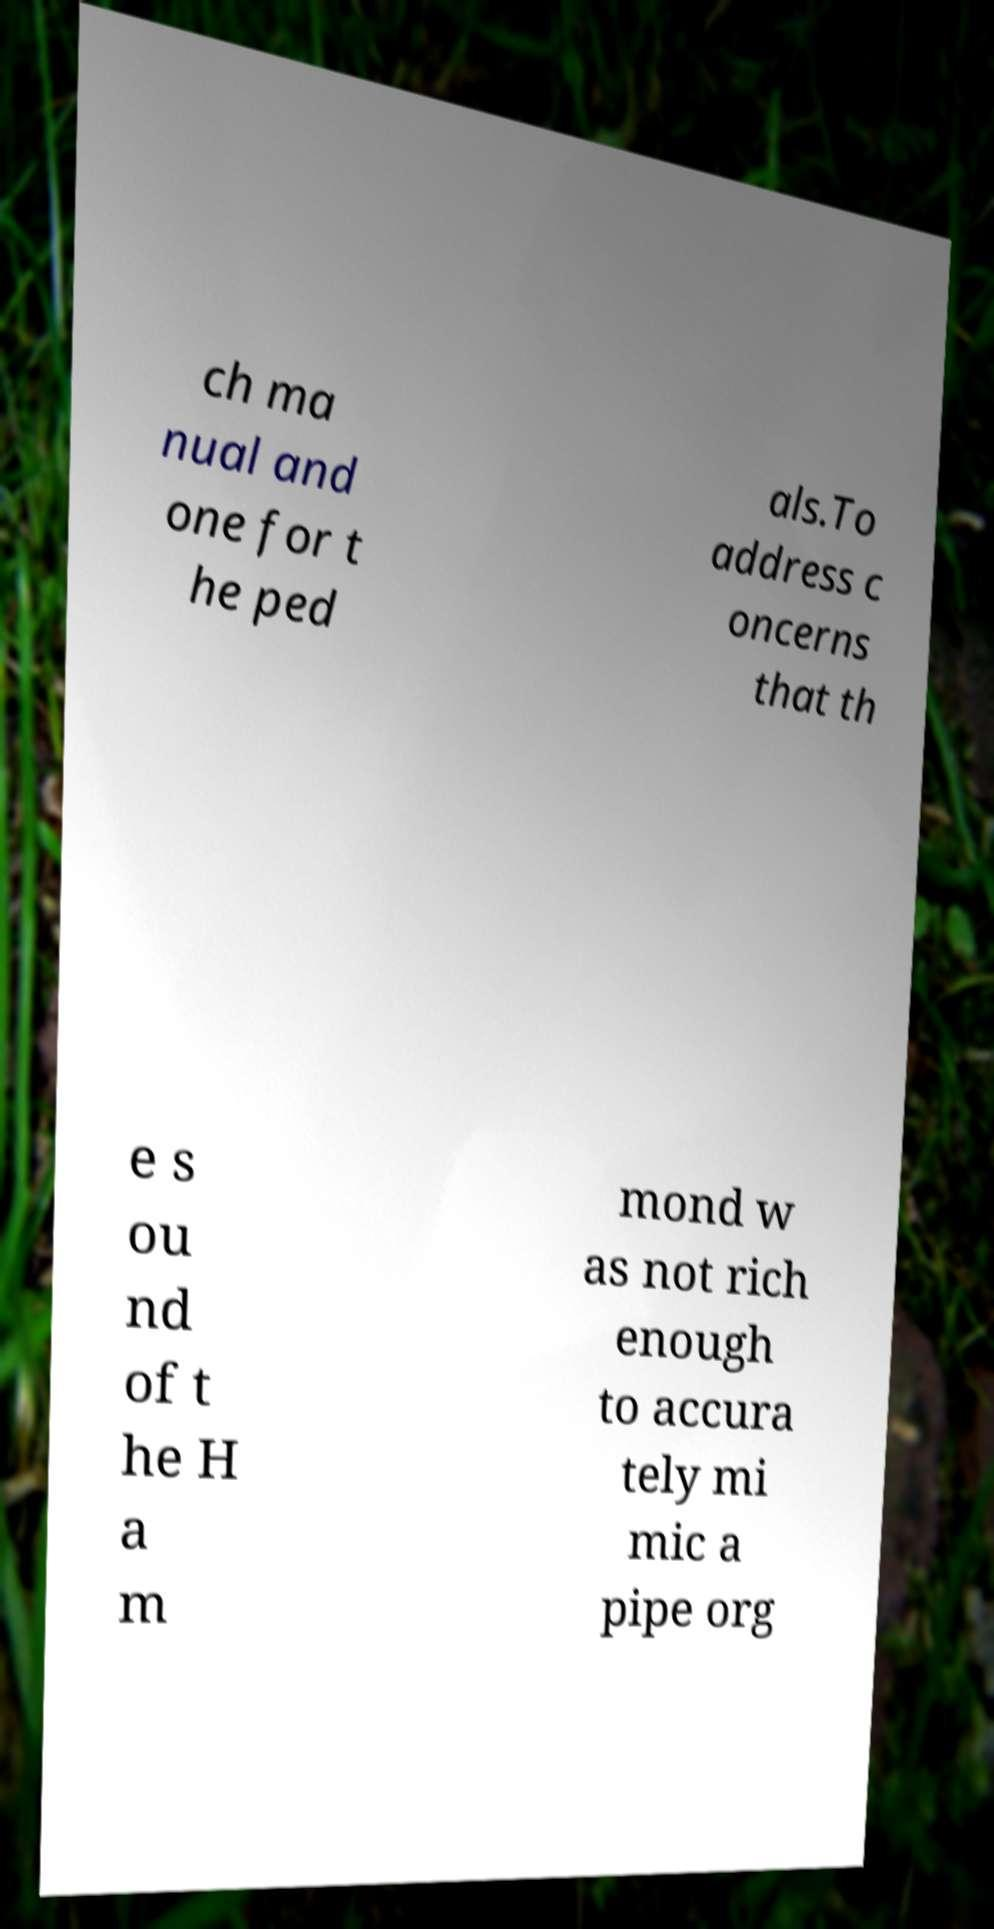What messages or text are displayed in this image? I need them in a readable, typed format. ch ma nual and one for t he ped als.To address c oncerns that th e s ou nd of t he H a m mond w as not rich enough to accura tely mi mic a pipe org 